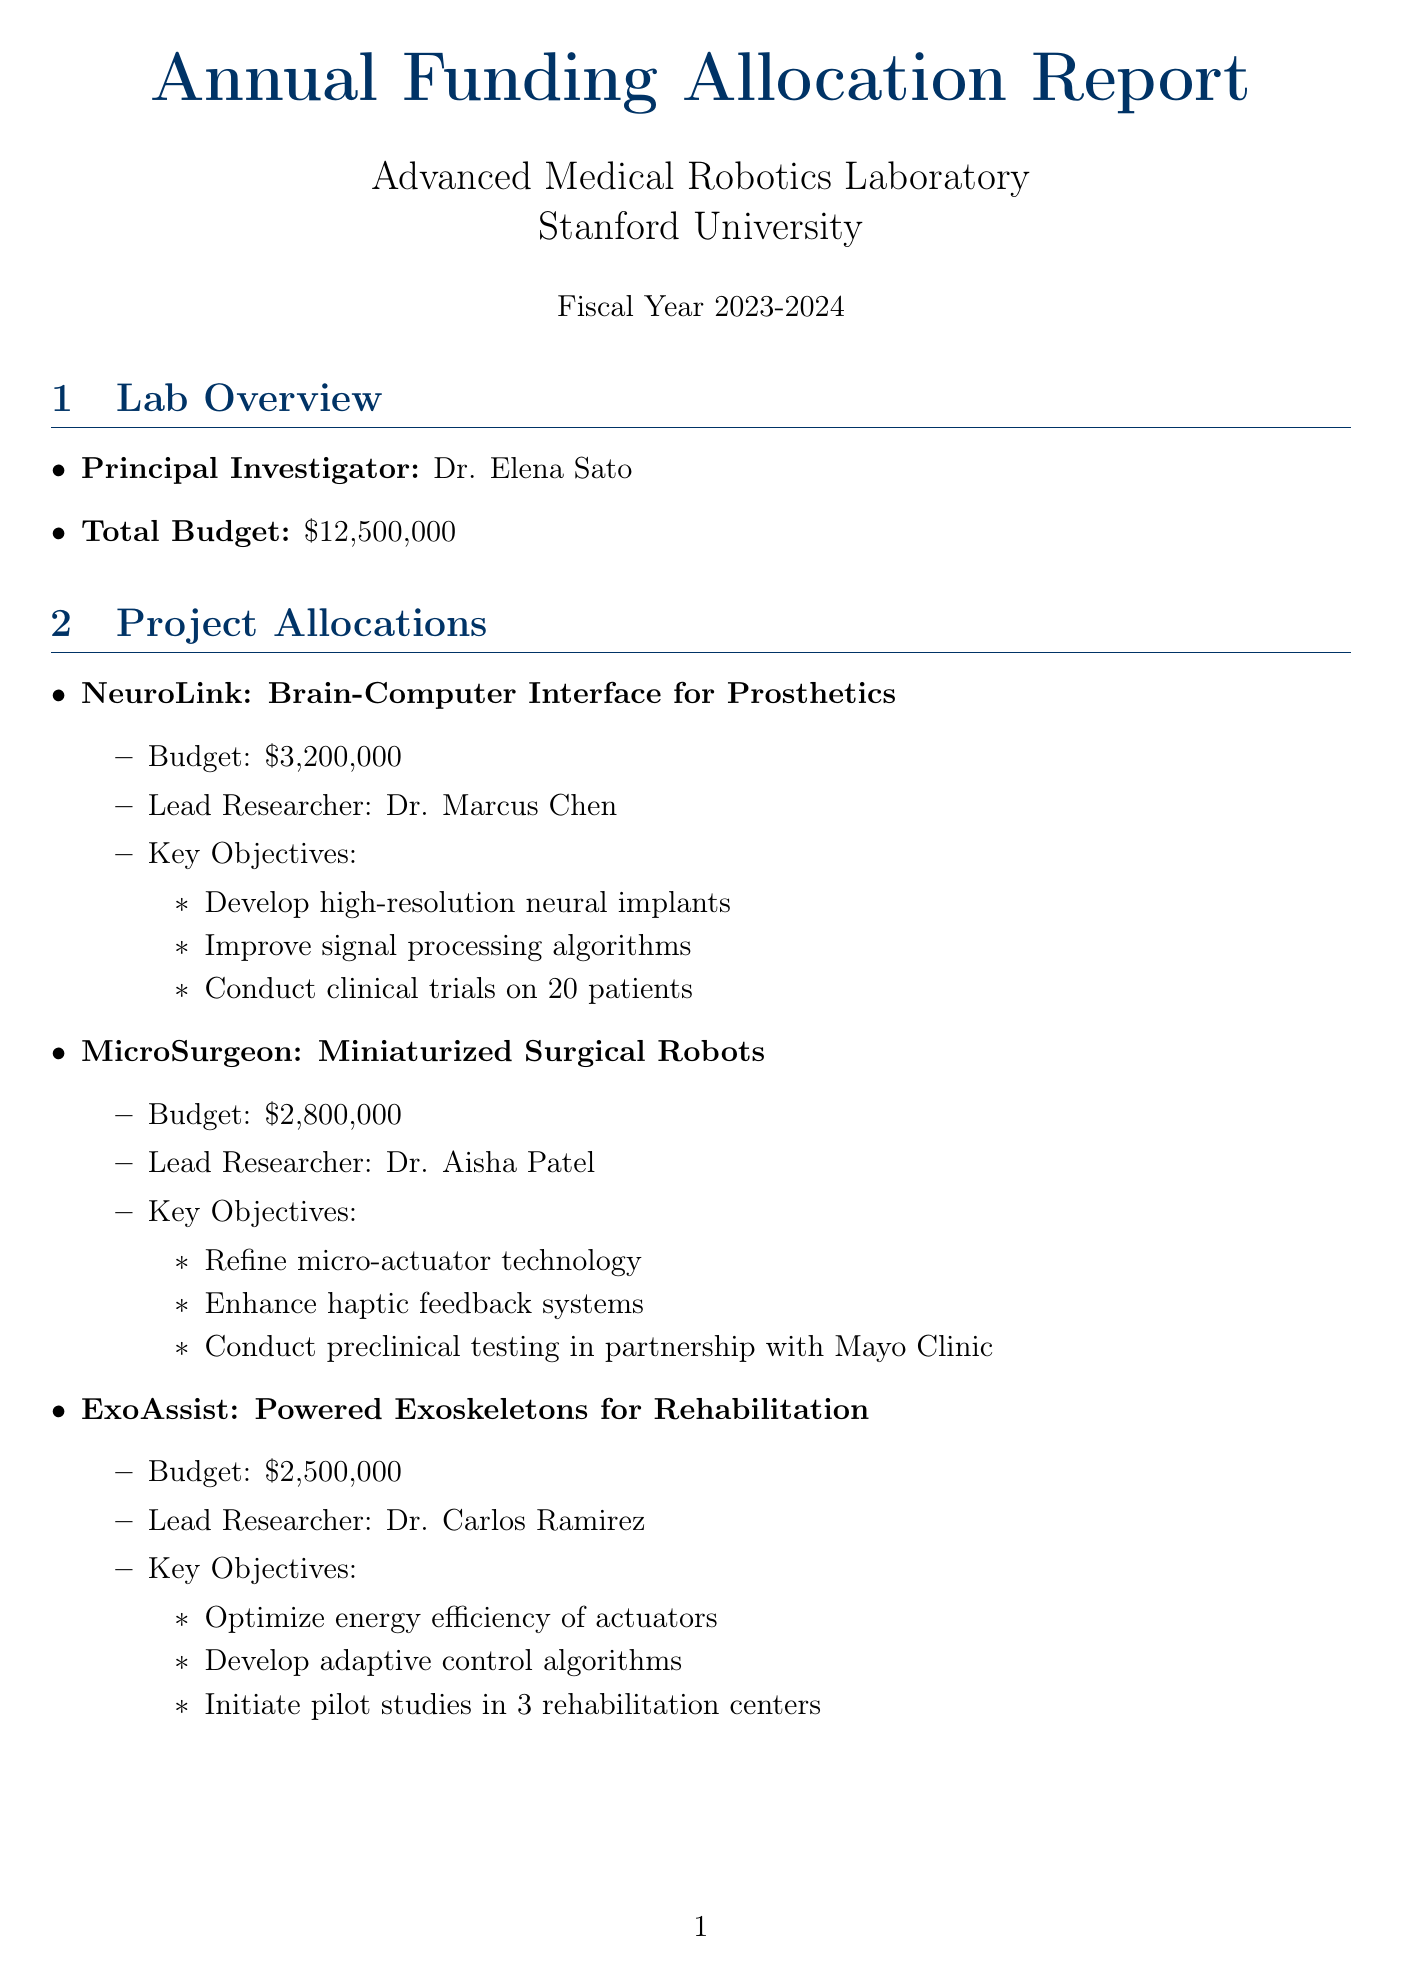What is the total budget for the lab? The total budget is provided in the lab overview section of the document.
Answer: $12,500,000 Who is the lead researcher for the ExoAssist project? The lead researcher for each project is mentioned in the project allocations section.
Answer: Dr. Carlos Ramirez What is the budget allocated for the NeuroLink project? The budget for each project can be found under the project allocations section.
Answer: $3,200,000 What equipment costs $6,500,000? The equipment acquisitions section lists the cost of each item.
Answer: Siemens MAGNETOM Terra 7T MRI Scanner What percentage is the expected budget increase for the next fiscal year? The expected budget increase is mentioned in the future projections section.
Answer: 8% Who are the funding partners listed in the document? The funding sources section outlines the various partners and amounts.
Answer: NIH, NSF, Stanford Medicine, Johnson & Johnson Innovation, Medtronic How many patents have been filed according to the performance metrics? The number of patents filed is documented under performance metrics.
Answer: 7 What is the date of the major grant application submission to DARPA? The submission date for each major grant application is specified in the future projections section.
Answer: March 15, 2024 How many graduate students are supported by the lab this year? The number of graduate students supported is included in the performance metrics.
Answer: 25 